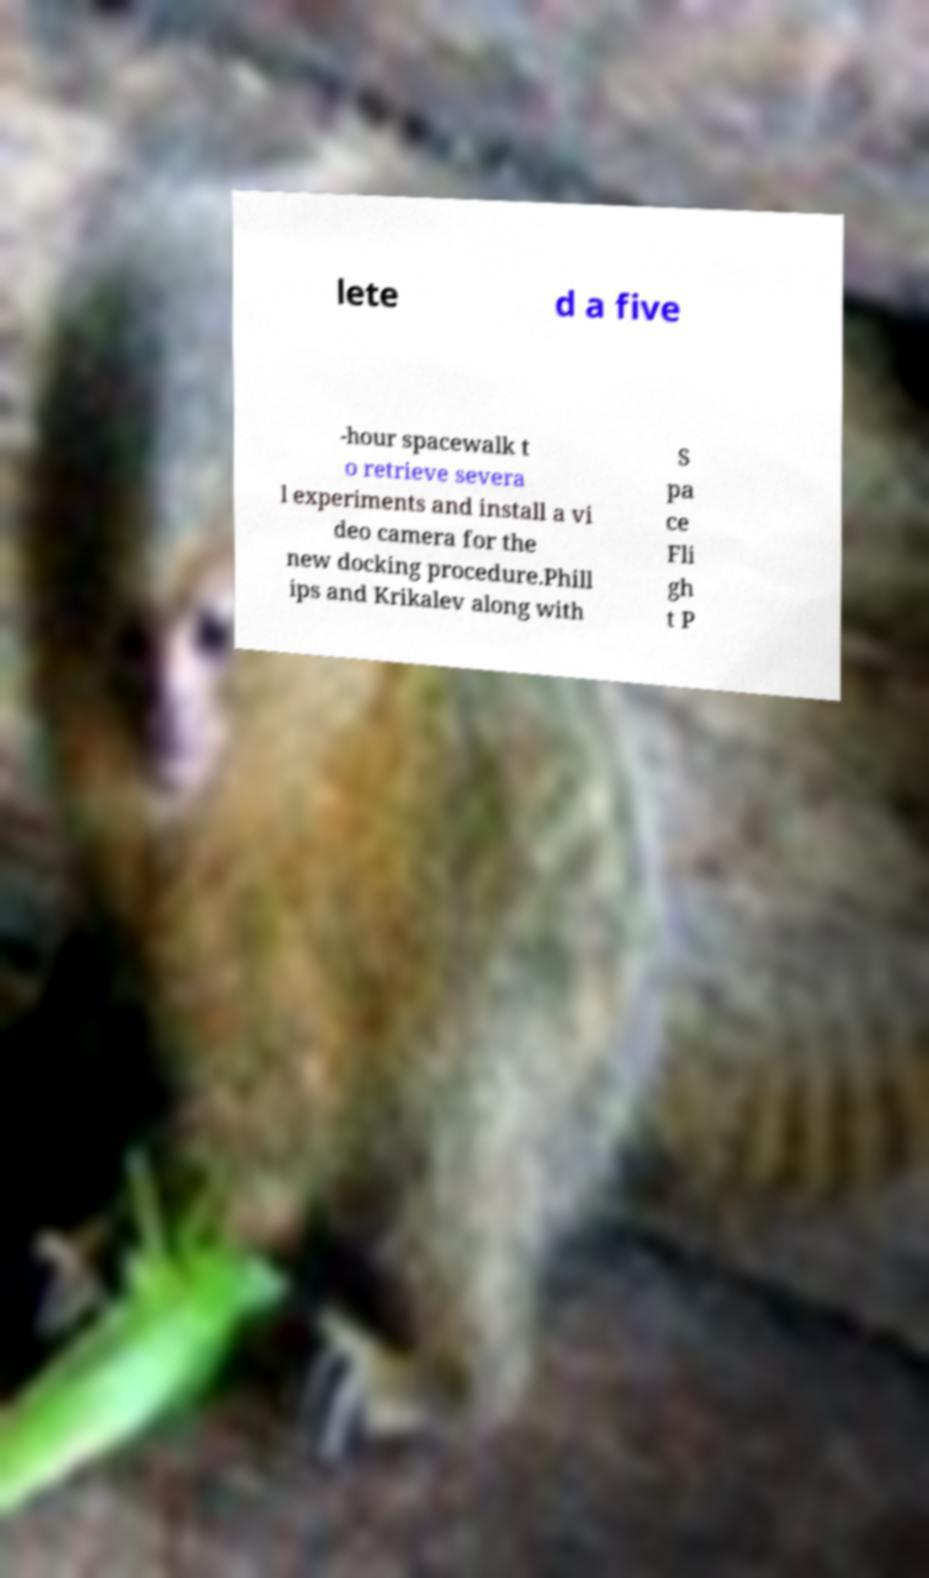Please identify and transcribe the text found in this image. lete d a five -hour spacewalk t o retrieve severa l experiments and install a vi deo camera for the new docking procedure.Phill ips and Krikalev along with S pa ce Fli gh t P 